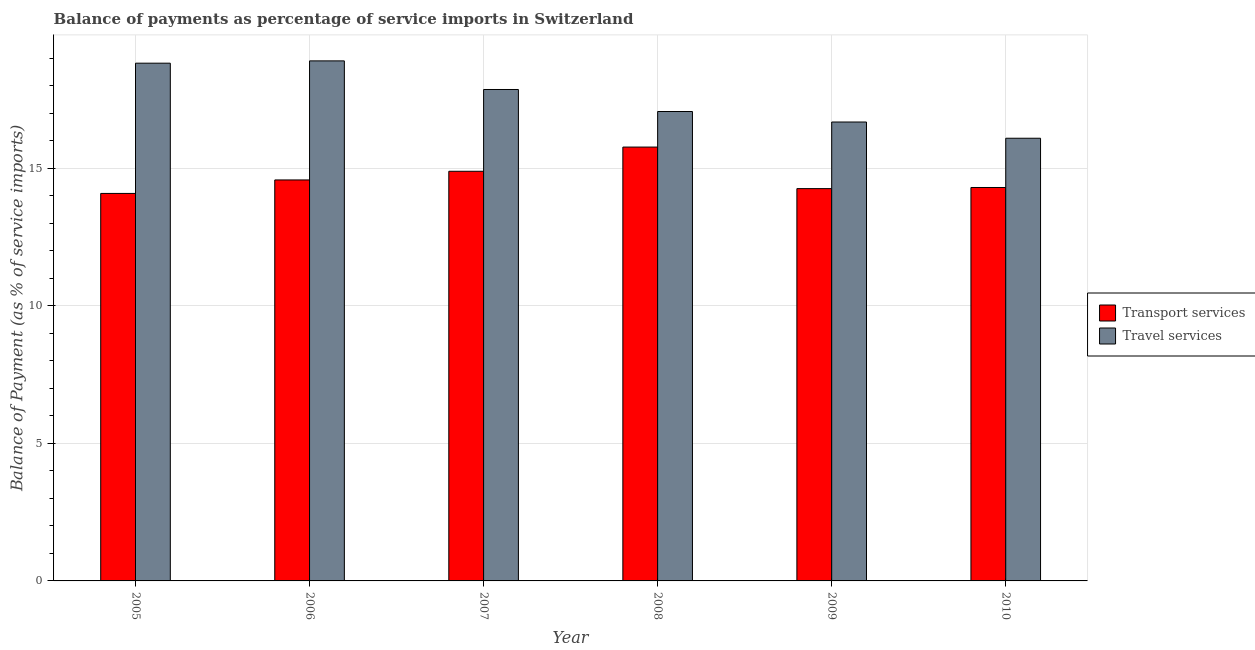How many bars are there on the 1st tick from the left?
Offer a terse response. 2. What is the label of the 6th group of bars from the left?
Offer a very short reply. 2010. What is the balance of payments of transport services in 2007?
Make the answer very short. 14.9. Across all years, what is the maximum balance of payments of transport services?
Offer a very short reply. 15.78. Across all years, what is the minimum balance of payments of travel services?
Your response must be concise. 16.1. In which year was the balance of payments of transport services maximum?
Ensure brevity in your answer.  2008. In which year was the balance of payments of transport services minimum?
Provide a succinct answer. 2005. What is the total balance of payments of transport services in the graph?
Give a very brief answer. 87.92. What is the difference between the balance of payments of transport services in 2005 and that in 2006?
Your answer should be compact. -0.49. What is the difference between the balance of payments of travel services in 2006 and the balance of payments of transport services in 2007?
Your answer should be very brief. 1.04. What is the average balance of payments of travel services per year?
Offer a terse response. 17.58. In how many years, is the balance of payments of travel services greater than 3 %?
Your answer should be compact. 6. What is the ratio of the balance of payments of transport services in 2007 to that in 2009?
Your response must be concise. 1.04. Is the difference between the balance of payments of travel services in 2007 and 2009 greater than the difference between the balance of payments of transport services in 2007 and 2009?
Give a very brief answer. No. What is the difference between the highest and the second highest balance of payments of travel services?
Ensure brevity in your answer.  0.08. What is the difference between the highest and the lowest balance of payments of transport services?
Your response must be concise. 1.69. In how many years, is the balance of payments of travel services greater than the average balance of payments of travel services taken over all years?
Offer a very short reply. 3. Is the sum of the balance of payments of travel services in 2005 and 2008 greater than the maximum balance of payments of transport services across all years?
Give a very brief answer. Yes. What does the 2nd bar from the left in 2006 represents?
Offer a terse response. Travel services. What does the 2nd bar from the right in 2010 represents?
Your response must be concise. Transport services. How many years are there in the graph?
Provide a succinct answer. 6. Are the values on the major ticks of Y-axis written in scientific E-notation?
Offer a terse response. No. Where does the legend appear in the graph?
Provide a succinct answer. Center right. How many legend labels are there?
Make the answer very short. 2. How are the legend labels stacked?
Make the answer very short. Vertical. What is the title of the graph?
Offer a very short reply. Balance of payments as percentage of service imports in Switzerland. What is the label or title of the Y-axis?
Offer a terse response. Balance of Payment (as % of service imports). What is the Balance of Payment (as % of service imports) of Transport services in 2005?
Make the answer very short. 14.09. What is the Balance of Payment (as % of service imports) of Travel services in 2005?
Offer a terse response. 18.83. What is the Balance of Payment (as % of service imports) of Transport services in 2006?
Make the answer very short. 14.58. What is the Balance of Payment (as % of service imports) in Travel services in 2006?
Your answer should be very brief. 18.91. What is the Balance of Payment (as % of service imports) of Transport services in 2007?
Your answer should be compact. 14.9. What is the Balance of Payment (as % of service imports) in Travel services in 2007?
Your answer should be very brief. 17.87. What is the Balance of Payment (as % of service imports) of Transport services in 2008?
Provide a short and direct response. 15.78. What is the Balance of Payment (as % of service imports) of Travel services in 2008?
Offer a very short reply. 17.07. What is the Balance of Payment (as % of service imports) of Transport services in 2009?
Your answer should be very brief. 14.27. What is the Balance of Payment (as % of service imports) of Travel services in 2009?
Give a very brief answer. 16.69. What is the Balance of Payment (as % of service imports) of Transport services in 2010?
Keep it short and to the point. 14.31. What is the Balance of Payment (as % of service imports) of Travel services in 2010?
Offer a very short reply. 16.1. Across all years, what is the maximum Balance of Payment (as % of service imports) in Transport services?
Offer a very short reply. 15.78. Across all years, what is the maximum Balance of Payment (as % of service imports) in Travel services?
Give a very brief answer. 18.91. Across all years, what is the minimum Balance of Payment (as % of service imports) of Transport services?
Offer a very short reply. 14.09. Across all years, what is the minimum Balance of Payment (as % of service imports) in Travel services?
Provide a succinct answer. 16.1. What is the total Balance of Payment (as % of service imports) in Transport services in the graph?
Keep it short and to the point. 87.92. What is the total Balance of Payment (as % of service imports) in Travel services in the graph?
Offer a terse response. 105.46. What is the difference between the Balance of Payment (as % of service imports) in Transport services in 2005 and that in 2006?
Provide a succinct answer. -0.49. What is the difference between the Balance of Payment (as % of service imports) in Travel services in 2005 and that in 2006?
Make the answer very short. -0.08. What is the difference between the Balance of Payment (as % of service imports) of Transport services in 2005 and that in 2007?
Ensure brevity in your answer.  -0.81. What is the difference between the Balance of Payment (as % of service imports) in Travel services in 2005 and that in 2007?
Offer a terse response. 0.96. What is the difference between the Balance of Payment (as % of service imports) of Transport services in 2005 and that in 2008?
Offer a very short reply. -1.69. What is the difference between the Balance of Payment (as % of service imports) of Travel services in 2005 and that in 2008?
Your response must be concise. 1.76. What is the difference between the Balance of Payment (as % of service imports) in Transport services in 2005 and that in 2009?
Make the answer very short. -0.17. What is the difference between the Balance of Payment (as % of service imports) in Travel services in 2005 and that in 2009?
Provide a short and direct response. 2.14. What is the difference between the Balance of Payment (as % of service imports) in Transport services in 2005 and that in 2010?
Your answer should be compact. -0.22. What is the difference between the Balance of Payment (as % of service imports) of Travel services in 2005 and that in 2010?
Your answer should be very brief. 2.73. What is the difference between the Balance of Payment (as % of service imports) of Transport services in 2006 and that in 2007?
Provide a succinct answer. -0.32. What is the difference between the Balance of Payment (as % of service imports) of Travel services in 2006 and that in 2007?
Ensure brevity in your answer.  1.04. What is the difference between the Balance of Payment (as % of service imports) in Transport services in 2006 and that in 2008?
Ensure brevity in your answer.  -1.2. What is the difference between the Balance of Payment (as % of service imports) of Travel services in 2006 and that in 2008?
Your answer should be very brief. 1.84. What is the difference between the Balance of Payment (as % of service imports) of Transport services in 2006 and that in 2009?
Keep it short and to the point. 0.32. What is the difference between the Balance of Payment (as % of service imports) of Travel services in 2006 and that in 2009?
Give a very brief answer. 2.22. What is the difference between the Balance of Payment (as % of service imports) in Transport services in 2006 and that in 2010?
Give a very brief answer. 0.27. What is the difference between the Balance of Payment (as % of service imports) in Travel services in 2006 and that in 2010?
Provide a short and direct response. 2.81. What is the difference between the Balance of Payment (as % of service imports) in Transport services in 2007 and that in 2008?
Keep it short and to the point. -0.88. What is the difference between the Balance of Payment (as % of service imports) in Travel services in 2007 and that in 2008?
Offer a terse response. 0.8. What is the difference between the Balance of Payment (as % of service imports) in Transport services in 2007 and that in 2009?
Give a very brief answer. 0.63. What is the difference between the Balance of Payment (as % of service imports) of Travel services in 2007 and that in 2009?
Your response must be concise. 1.18. What is the difference between the Balance of Payment (as % of service imports) in Transport services in 2007 and that in 2010?
Your answer should be very brief. 0.59. What is the difference between the Balance of Payment (as % of service imports) of Travel services in 2007 and that in 2010?
Give a very brief answer. 1.77. What is the difference between the Balance of Payment (as % of service imports) in Transport services in 2008 and that in 2009?
Ensure brevity in your answer.  1.51. What is the difference between the Balance of Payment (as % of service imports) of Travel services in 2008 and that in 2009?
Provide a short and direct response. 0.38. What is the difference between the Balance of Payment (as % of service imports) in Transport services in 2008 and that in 2010?
Keep it short and to the point. 1.47. What is the difference between the Balance of Payment (as % of service imports) in Travel services in 2008 and that in 2010?
Keep it short and to the point. 0.97. What is the difference between the Balance of Payment (as % of service imports) in Transport services in 2009 and that in 2010?
Give a very brief answer. -0.04. What is the difference between the Balance of Payment (as % of service imports) of Travel services in 2009 and that in 2010?
Your answer should be compact. 0.59. What is the difference between the Balance of Payment (as % of service imports) in Transport services in 2005 and the Balance of Payment (as % of service imports) in Travel services in 2006?
Give a very brief answer. -4.82. What is the difference between the Balance of Payment (as % of service imports) in Transport services in 2005 and the Balance of Payment (as % of service imports) in Travel services in 2007?
Provide a succinct answer. -3.78. What is the difference between the Balance of Payment (as % of service imports) of Transport services in 2005 and the Balance of Payment (as % of service imports) of Travel services in 2008?
Make the answer very short. -2.98. What is the difference between the Balance of Payment (as % of service imports) in Transport services in 2005 and the Balance of Payment (as % of service imports) in Travel services in 2009?
Your response must be concise. -2.6. What is the difference between the Balance of Payment (as % of service imports) in Transport services in 2005 and the Balance of Payment (as % of service imports) in Travel services in 2010?
Make the answer very short. -2.01. What is the difference between the Balance of Payment (as % of service imports) in Transport services in 2006 and the Balance of Payment (as % of service imports) in Travel services in 2007?
Provide a succinct answer. -3.29. What is the difference between the Balance of Payment (as % of service imports) of Transport services in 2006 and the Balance of Payment (as % of service imports) of Travel services in 2008?
Keep it short and to the point. -2.49. What is the difference between the Balance of Payment (as % of service imports) in Transport services in 2006 and the Balance of Payment (as % of service imports) in Travel services in 2009?
Provide a succinct answer. -2.11. What is the difference between the Balance of Payment (as % of service imports) in Transport services in 2006 and the Balance of Payment (as % of service imports) in Travel services in 2010?
Provide a short and direct response. -1.52. What is the difference between the Balance of Payment (as % of service imports) in Transport services in 2007 and the Balance of Payment (as % of service imports) in Travel services in 2008?
Provide a short and direct response. -2.17. What is the difference between the Balance of Payment (as % of service imports) of Transport services in 2007 and the Balance of Payment (as % of service imports) of Travel services in 2009?
Offer a very short reply. -1.79. What is the difference between the Balance of Payment (as % of service imports) of Transport services in 2007 and the Balance of Payment (as % of service imports) of Travel services in 2010?
Offer a terse response. -1.2. What is the difference between the Balance of Payment (as % of service imports) of Transport services in 2008 and the Balance of Payment (as % of service imports) of Travel services in 2009?
Keep it short and to the point. -0.91. What is the difference between the Balance of Payment (as % of service imports) in Transport services in 2008 and the Balance of Payment (as % of service imports) in Travel services in 2010?
Give a very brief answer. -0.32. What is the difference between the Balance of Payment (as % of service imports) in Transport services in 2009 and the Balance of Payment (as % of service imports) in Travel services in 2010?
Provide a short and direct response. -1.83. What is the average Balance of Payment (as % of service imports) of Transport services per year?
Make the answer very short. 14.65. What is the average Balance of Payment (as % of service imports) in Travel services per year?
Provide a succinct answer. 17.58. In the year 2005, what is the difference between the Balance of Payment (as % of service imports) of Transport services and Balance of Payment (as % of service imports) of Travel services?
Give a very brief answer. -4.74. In the year 2006, what is the difference between the Balance of Payment (as % of service imports) in Transport services and Balance of Payment (as % of service imports) in Travel services?
Provide a succinct answer. -4.33. In the year 2007, what is the difference between the Balance of Payment (as % of service imports) in Transport services and Balance of Payment (as % of service imports) in Travel services?
Your answer should be compact. -2.97. In the year 2008, what is the difference between the Balance of Payment (as % of service imports) of Transport services and Balance of Payment (as % of service imports) of Travel services?
Provide a succinct answer. -1.29. In the year 2009, what is the difference between the Balance of Payment (as % of service imports) in Transport services and Balance of Payment (as % of service imports) in Travel services?
Offer a terse response. -2.42. In the year 2010, what is the difference between the Balance of Payment (as % of service imports) of Transport services and Balance of Payment (as % of service imports) of Travel services?
Your answer should be compact. -1.79. What is the ratio of the Balance of Payment (as % of service imports) in Transport services in 2005 to that in 2006?
Your answer should be very brief. 0.97. What is the ratio of the Balance of Payment (as % of service imports) in Transport services in 2005 to that in 2007?
Make the answer very short. 0.95. What is the ratio of the Balance of Payment (as % of service imports) in Travel services in 2005 to that in 2007?
Make the answer very short. 1.05. What is the ratio of the Balance of Payment (as % of service imports) in Transport services in 2005 to that in 2008?
Your answer should be very brief. 0.89. What is the ratio of the Balance of Payment (as % of service imports) in Travel services in 2005 to that in 2008?
Offer a terse response. 1.1. What is the ratio of the Balance of Payment (as % of service imports) of Travel services in 2005 to that in 2009?
Keep it short and to the point. 1.13. What is the ratio of the Balance of Payment (as % of service imports) in Transport services in 2005 to that in 2010?
Provide a short and direct response. 0.98. What is the ratio of the Balance of Payment (as % of service imports) in Travel services in 2005 to that in 2010?
Your answer should be compact. 1.17. What is the ratio of the Balance of Payment (as % of service imports) in Transport services in 2006 to that in 2007?
Provide a short and direct response. 0.98. What is the ratio of the Balance of Payment (as % of service imports) of Travel services in 2006 to that in 2007?
Give a very brief answer. 1.06. What is the ratio of the Balance of Payment (as % of service imports) in Transport services in 2006 to that in 2008?
Keep it short and to the point. 0.92. What is the ratio of the Balance of Payment (as % of service imports) of Travel services in 2006 to that in 2008?
Offer a terse response. 1.11. What is the ratio of the Balance of Payment (as % of service imports) of Transport services in 2006 to that in 2009?
Give a very brief answer. 1.02. What is the ratio of the Balance of Payment (as % of service imports) of Travel services in 2006 to that in 2009?
Give a very brief answer. 1.13. What is the ratio of the Balance of Payment (as % of service imports) of Transport services in 2006 to that in 2010?
Ensure brevity in your answer.  1.02. What is the ratio of the Balance of Payment (as % of service imports) in Travel services in 2006 to that in 2010?
Your answer should be compact. 1.17. What is the ratio of the Balance of Payment (as % of service imports) of Transport services in 2007 to that in 2008?
Give a very brief answer. 0.94. What is the ratio of the Balance of Payment (as % of service imports) in Travel services in 2007 to that in 2008?
Keep it short and to the point. 1.05. What is the ratio of the Balance of Payment (as % of service imports) in Transport services in 2007 to that in 2009?
Provide a short and direct response. 1.04. What is the ratio of the Balance of Payment (as % of service imports) in Travel services in 2007 to that in 2009?
Provide a succinct answer. 1.07. What is the ratio of the Balance of Payment (as % of service imports) of Transport services in 2007 to that in 2010?
Your answer should be compact. 1.04. What is the ratio of the Balance of Payment (as % of service imports) of Travel services in 2007 to that in 2010?
Your response must be concise. 1.11. What is the ratio of the Balance of Payment (as % of service imports) in Transport services in 2008 to that in 2009?
Provide a short and direct response. 1.11. What is the ratio of the Balance of Payment (as % of service imports) of Travel services in 2008 to that in 2009?
Offer a terse response. 1.02. What is the ratio of the Balance of Payment (as % of service imports) in Transport services in 2008 to that in 2010?
Your answer should be very brief. 1.1. What is the ratio of the Balance of Payment (as % of service imports) of Travel services in 2008 to that in 2010?
Your answer should be very brief. 1.06. What is the ratio of the Balance of Payment (as % of service imports) in Transport services in 2009 to that in 2010?
Provide a succinct answer. 1. What is the ratio of the Balance of Payment (as % of service imports) in Travel services in 2009 to that in 2010?
Your response must be concise. 1.04. What is the difference between the highest and the second highest Balance of Payment (as % of service imports) in Transport services?
Make the answer very short. 0.88. What is the difference between the highest and the second highest Balance of Payment (as % of service imports) of Travel services?
Your answer should be very brief. 0.08. What is the difference between the highest and the lowest Balance of Payment (as % of service imports) of Transport services?
Offer a very short reply. 1.69. What is the difference between the highest and the lowest Balance of Payment (as % of service imports) of Travel services?
Keep it short and to the point. 2.81. 